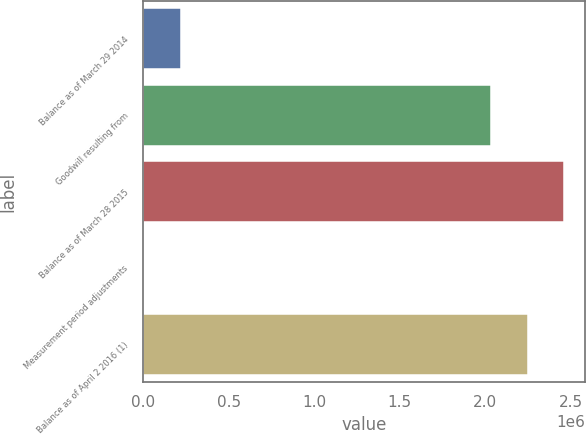Convert chart to OTSL. <chart><loc_0><loc_0><loc_500><loc_500><bar_chart><fcel>Balance as of March 29 2014<fcel>Goodwill resulting from<fcel>Balance as of March 28 2015<fcel>Measurement period adjustments<fcel>Balance as of April 2 2016 (1)<nl><fcel>218459<fcel>2.03668e+06<fcel>2.46382e+06<fcel>4889<fcel>2.25025e+06<nl></chart> 